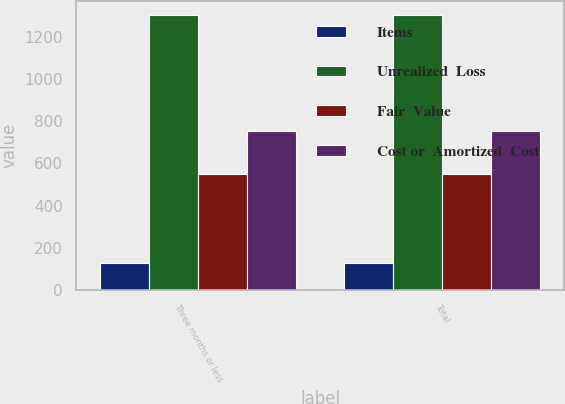Convert chart to OTSL. <chart><loc_0><loc_0><loc_500><loc_500><stacked_bar_chart><ecel><fcel>Three months or less<fcel>Total<nl><fcel>Items<fcel>129<fcel>129<nl><fcel>Unrealized  Loss<fcel>1305<fcel>1305<nl><fcel>Fair  Value<fcel>549<fcel>549<nl><fcel>Cost or  Amortized  Cost<fcel>756<fcel>756<nl></chart> 